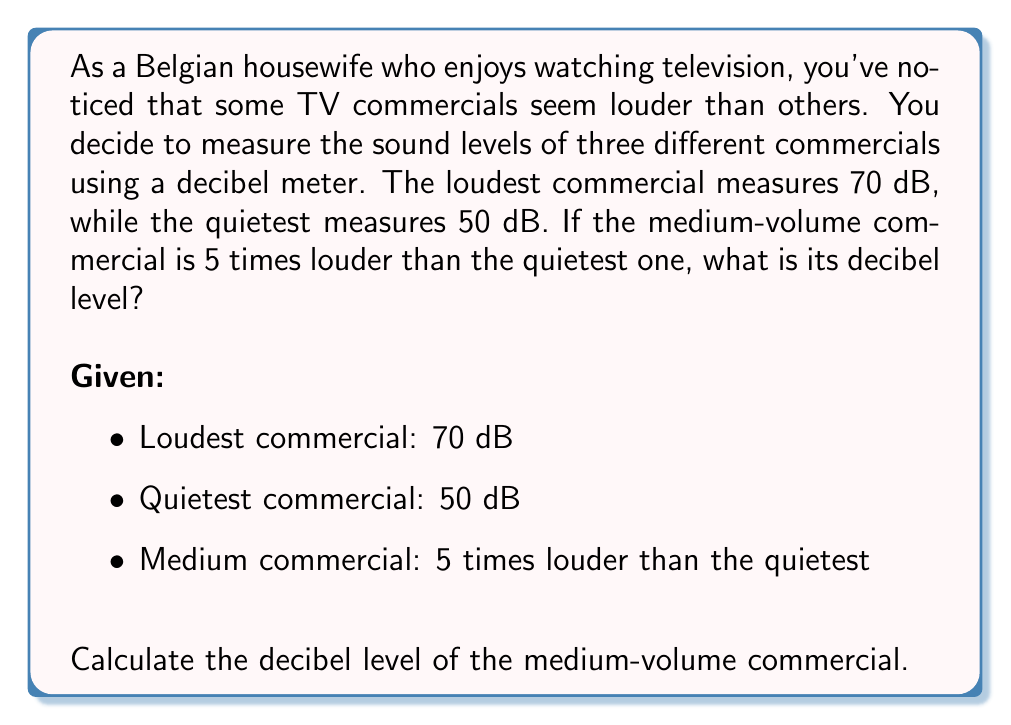Help me with this question. To solve this problem, we need to use the properties of logarithmic scales, specifically the decibel scale. Here's how we can approach it:

1) The decibel scale is logarithmic, based on powers of 10. The relationship between intensity and decibel level is:

   $$ dB = 10 \log_{10}\left(\frac{I}{I_0}\right) $$

   Where $I$ is the intensity of the sound and $I_0$ is a reference intensity.

2) We're told that the medium commercial is 5 times louder than the quietest. This refers to the intensity, not the decibel level. Let's call the intensity of the quietest commercial $I_q$ and the medium one $I_m$. Then:

   $$ I_m = 5I_q $$

3) We can express the difference in decibels between these two commercials:

   $$ dB_m - dB_q = 10 \log_{10}\left(\frac{I_m}{I_q}\right) $$

4) Substituting what we know:

   $$ dB_m - 50 = 10 \log_{10}\left(\frac{5I_q}{I_q}\right) = 10 \log_{10}(5) $$

5) Simplify:

   $$ dB_m - 50 = 10 \cdot 0.699 = 6.99 $$

6) Solve for $dB_m$:

   $$ dB_m = 50 + 6.99 = 56.99 $$

Therefore, the medium-volume commercial has a decibel level of approximately 57 dB.
Answer: The medium-volume commercial has a decibel level of approximately 57 dB. 